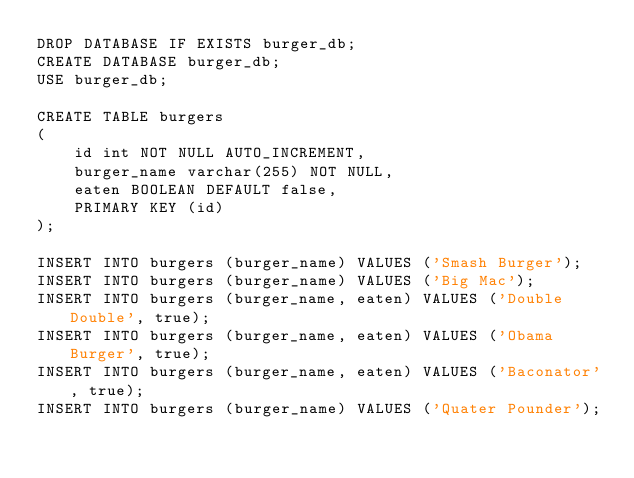Convert code to text. <code><loc_0><loc_0><loc_500><loc_500><_SQL_>DROP DATABASE IF EXISTS burger_db;
CREATE DATABASE burger_db;
USE burger_db;

CREATE TABLE burgers
(
	id int NOT NULL AUTO_INCREMENT,
	burger_name varchar(255) NOT NULL,
	eaten BOOLEAN DEFAULT false,
	PRIMARY KEY (id)
);
 
INSERT INTO burgers (burger_name) VALUES ('Smash Burger');
INSERT INTO burgers (burger_name) VALUES ('Big Mac');
INSERT INTO burgers (burger_name, eaten) VALUES ('Double Double', true);
INSERT INTO burgers (burger_name, eaten) VALUES ('Obama Burger', true);
INSERT INTO burgers (burger_name, eaten) VALUES ('Baconator', true);
INSERT INTO burgers (burger_name) VALUES ('Quater Pounder');</code> 